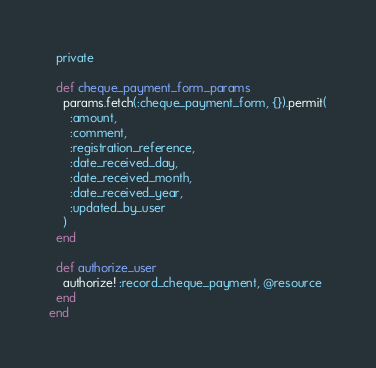<code> <loc_0><loc_0><loc_500><loc_500><_Ruby_>  private

  def cheque_payment_form_params
    params.fetch(:cheque_payment_form, {}).permit(
      :amount,
      :comment,
      :registration_reference,
      :date_received_day,
      :date_received_month,
      :date_received_year,
      :updated_by_user
    )
  end

  def authorize_user
    authorize! :record_cheque_payment, @resource
  end
end
</code> 